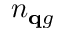<formula> <loc_0><loc_0><loc_500><loc_500>n _ { \mathbf q g }</formula> 